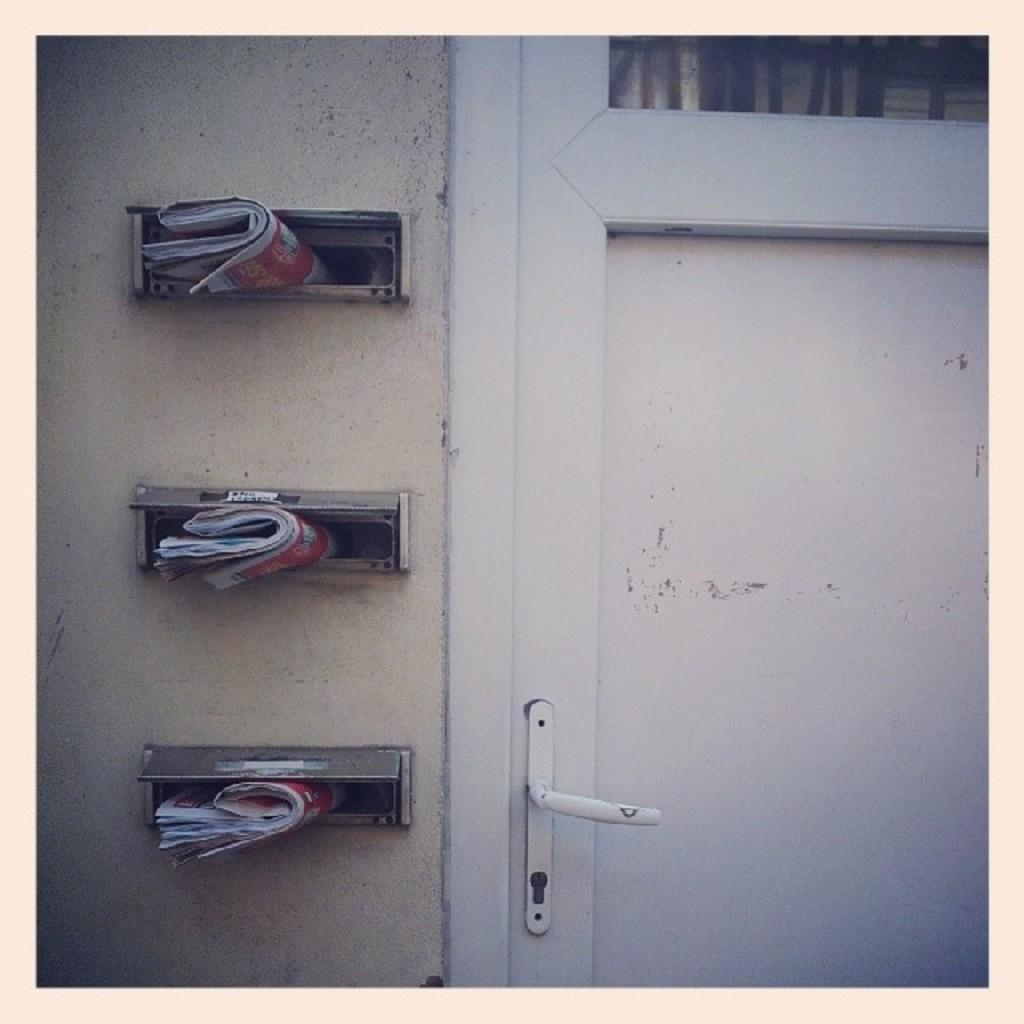What type of space is shown in the image? The image depicts a room. What can be seen on the wall in the room? There are outlets on the wall in the room. What is unusual about the outlets in the image? Papers are present in the outlets. How many frogs can be seen hopping around in the room? There are no frogs present in the image. What type of coat is hanging on the wall in the room? There is no coat visible in the image. 